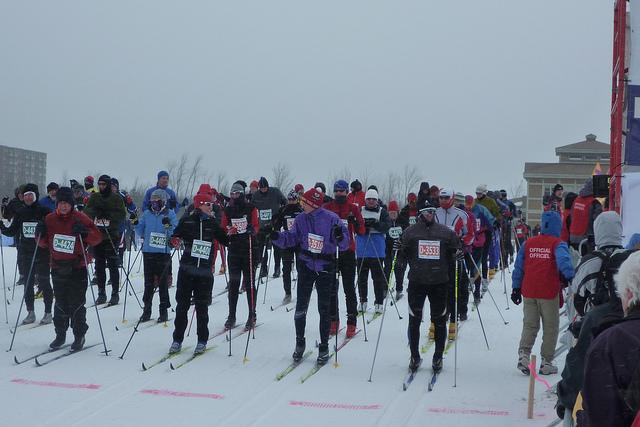What water sport do they participate in?
Quick response, please. Skiing. Is this summer event?
Keep it brief. No. What sport are these people participating in?
Answer briefly. Skiing. Is the day cold?
Write a very short answer. Yes. What kind of hats are the riders wearing?
Give a very brief answer. Beanies. What sport are they playing?
Answer briefly. Skiing. How many people are here?
Quick response, please. 50. Is everyone standing?
Quick response, please. Yes. Are the people going on vacation?
Concise answer only. No. How many women are wearing skirts?
Short answer required. 0. What sport is this?
Give a very brief answer. Skiing. What type of event are they attending?
Give a very brief answer. Skiing. What are the people doing?
Answer briefly. Skiing. What are the people waiting on?
Give a very brief answer. Race. What number of people are standing in the snow?
Write a very short answer. 40. Is this a parade?
Write a very short answer. No. Is this a race?
Be succinct. Yes. The people are having a what?
Write a very short answer. Race. What color are the men's hats?
Give a very brief answer. Varied. What are they doing?
Write a very short answer. Skiing. What number is this person wearing?
Answer briefly. I don't know. How many people are wearing hats?
Write a very short answer. 25. Is anyone not wearing a hat?
Write a very short answer. No. 